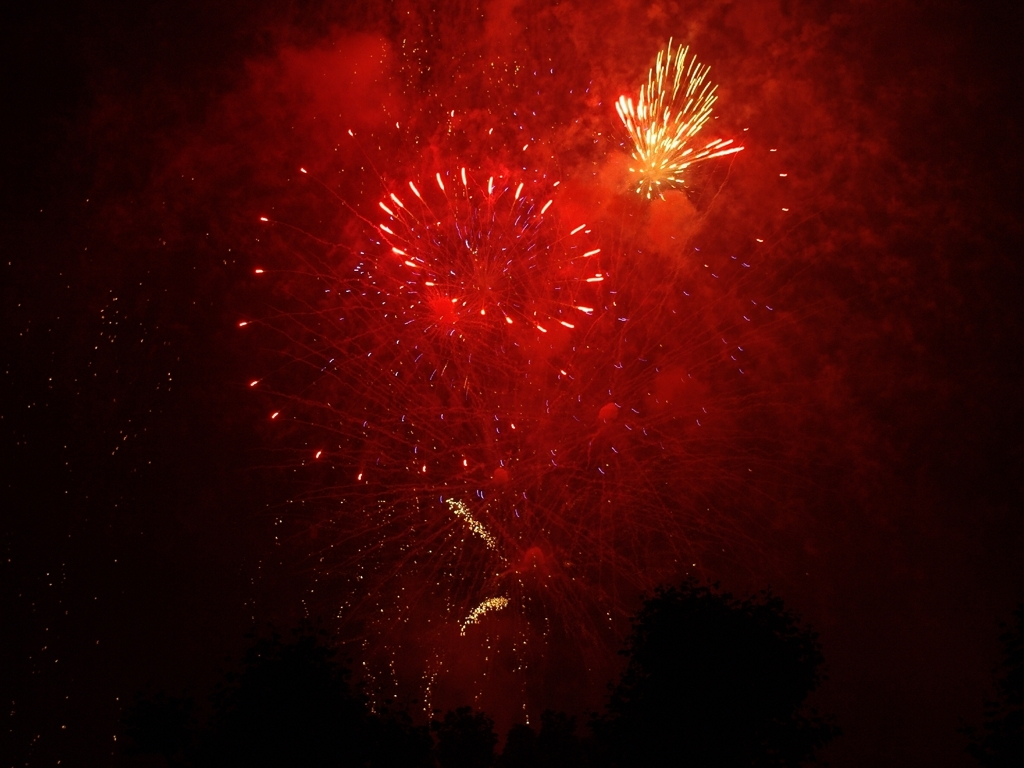What event or celebration could these fireworks be part of? Based on the vibrant and grand display of fireworks in the image, this could be part of a national holiday celebration, a festival, or a major public event such as New Year's Eve or Independence Day celebrations. 